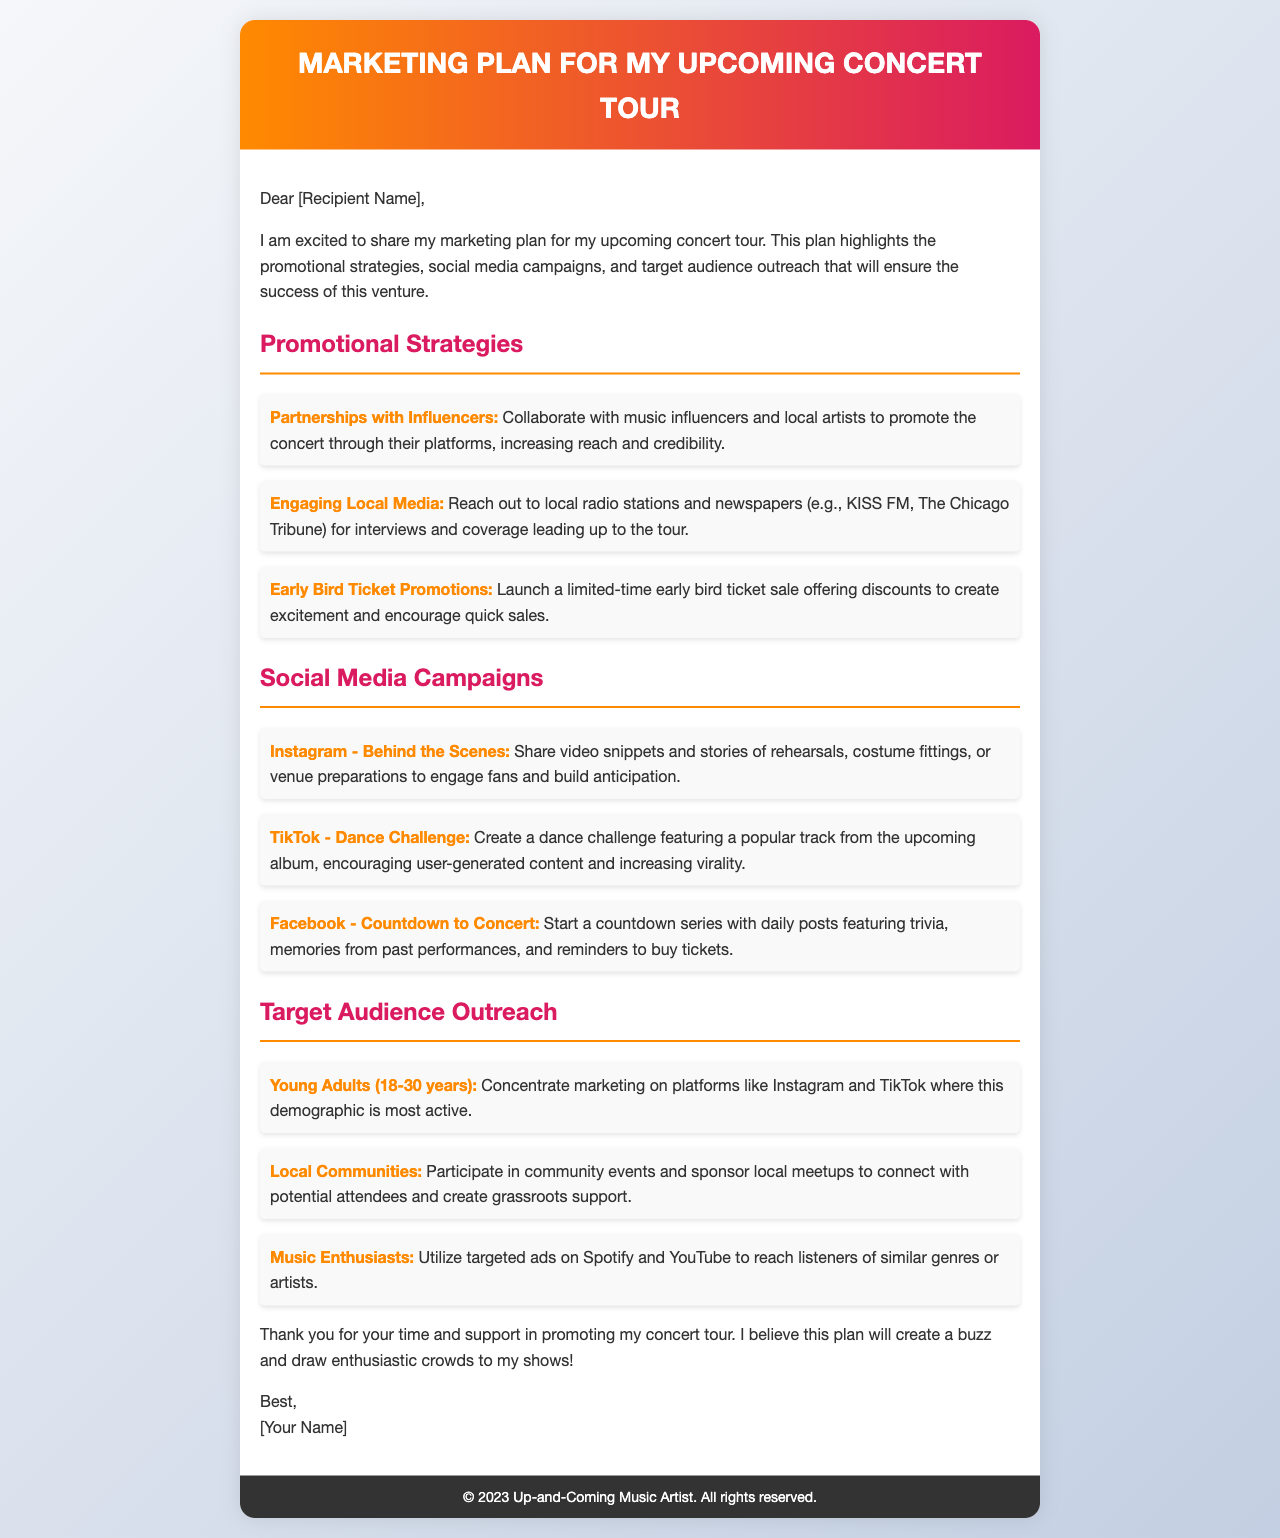What is the title of the document? The title of the document is mentioned at the top of the email.
Answer: Marketing Plan for My Upcoming Concert Tour Who is mentioned as a local media contact? Local media contacts are specified in the promotional strategies section of the document.
Answer: KISS FM, The Chicago Tribune What demographic is primarily targeted for social media marketing? The document specifies the primary demographic in the target audience outreach section.
Answer: Young Adults (18-30 years) What type of social media campaign involves user-generated content? The specific campaign type is noted under the social media campaigns section of the document.
Answer: TikTok - Dance Challenge How many promotional strategies are listed in the document? The number of promotional strategies can be counted from the list provided in the document.
Answer: Three 